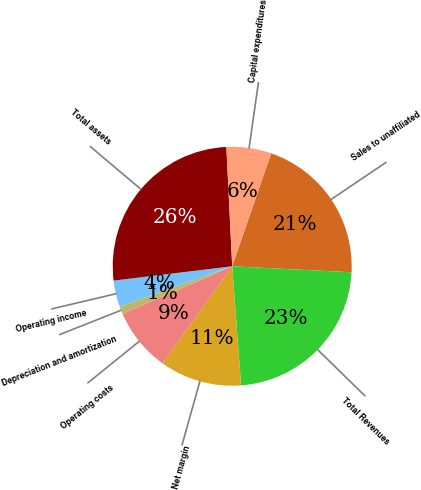Convert chart to OTSL. <chart><loc_0><loc_0><loc_500><loc_500><pie_chart><fcel>Sales to unaffiliated<fcel>Total Revenues<fcel>Net margin<fcel>Operating costs<fcel>Depreciation and amortization<fcel>Operating income<fcel>Total assets<fcel>Capital expenditures<nl><fcel>20.51%<fcel>23.02%<fcel>11.08%<fcel>8.58%<fcel>1.05%<fcel>3.56%<fcel>26.14%<fcel>6.07%<nl></chart> 